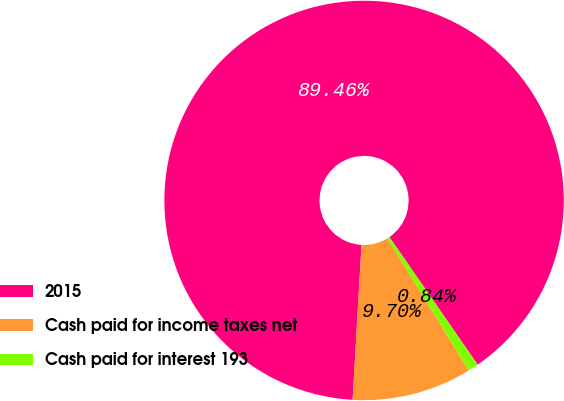Convert chart to OTSL. <chart><loc_0><loc_0><loc_500><loc_500><pie_chart><fcel>2015<fcel>Cash paid for income taxes net<fcel>Cash paid for interest 193<nl><fcel>89.45%<fcel>9.7%<fcel>0.84%<nl></chart> 